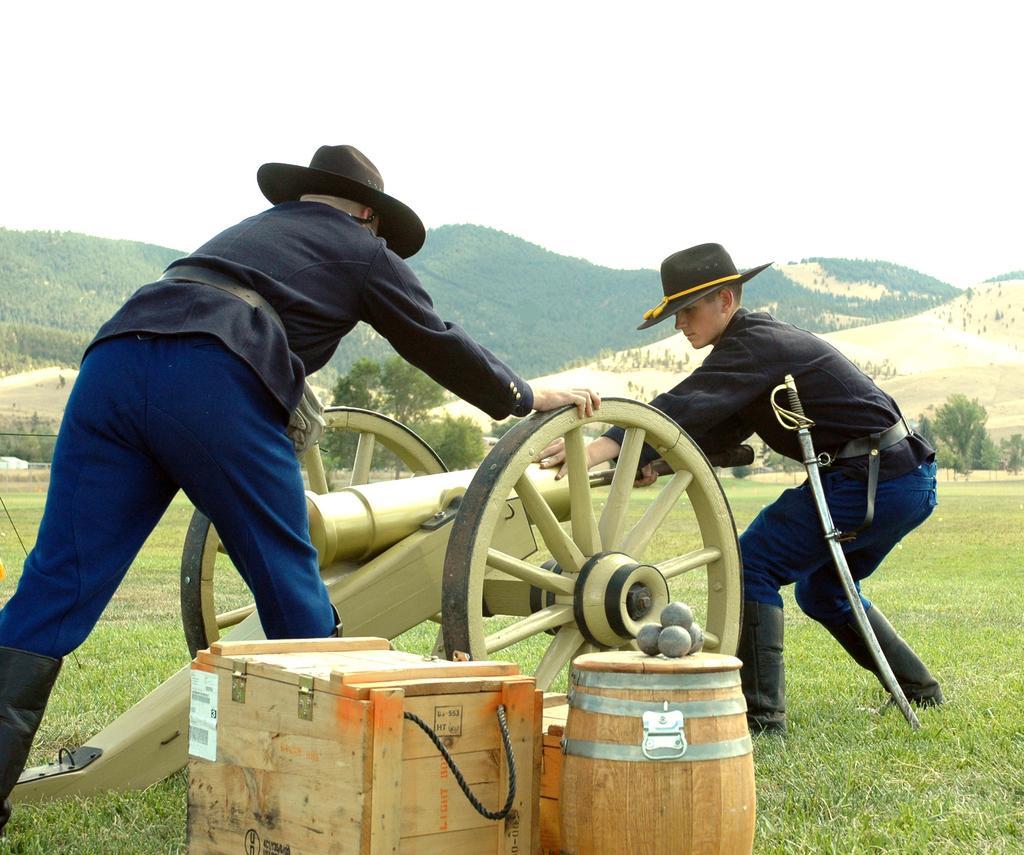How would you summarize this image in a sentence or two? In this picture I can see there are two people standing here and they are pushing a weapon and there are some boxes placed on the grass and in the backdrop I can see there are trees and mountains. The sky is clear. 